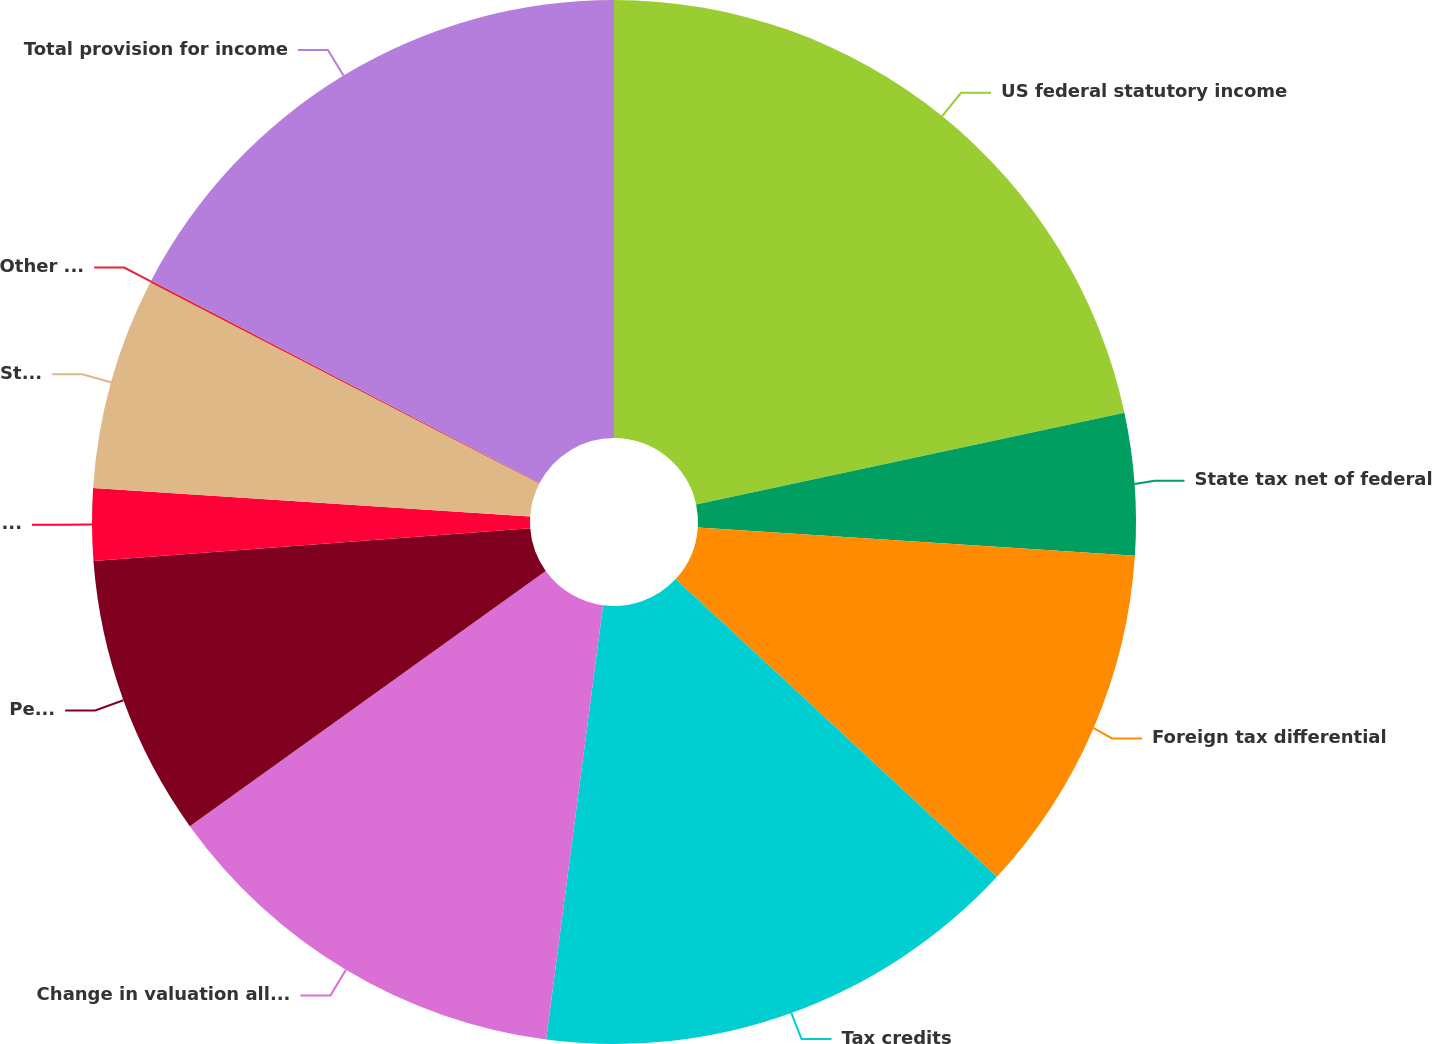Convert chart. <chart><loc_0><loc_0><loc_500><loc_500><pie_chart><fcel>US federal statutory income<fcel>State tax net of federal<fcel>Foreign tax differential<fcel>Tax credits<fcel>Change in valuation allowance<fcel>Permanent items<fcel>Uncertain tax positions and<fcel>Stock-based compensation<fcel>Other net<fcel>Total provision for income<nl><fcel>21.64%<fcel>4.39%<fcel>10.86%<fcel>15.18%<fcel>13.02%<fcel>8.71%<fcel>2.23%<fcel>6.55%<fcel>0.07%<fcel>17.34%<nl></chart> 